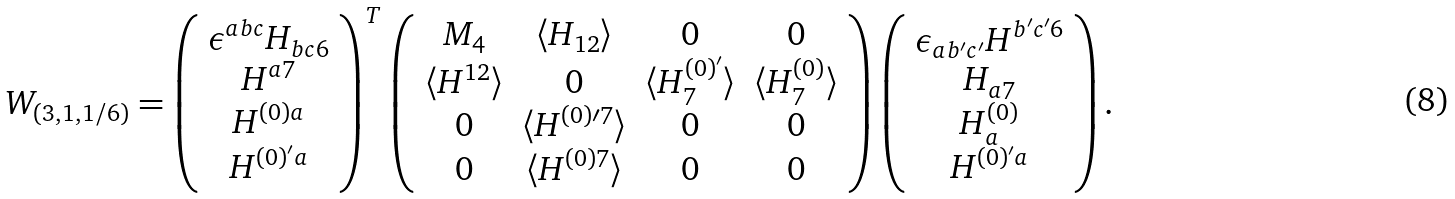<formula> <loc_0><loc_0><loc_500><loc_500>W _ { ( 3 , 1 , 1 / 6 ) } = \left ( \begin{array} { c } \epsilon ^ { a b c } H _ { b c 6 } \\ H ^ { a 7 } \\ H ^ { ( 0 ) a } \\ H ^ { ( 0 ) ^ { \prime } a } \end{array} \right ) ^ { T } \left ( \begin{array} { c c c c } M _ { 4 } & \langle H _ { 1 2 } \rangle & 0 & 0 \\ \langle H ^ { 1 2 } \rangle & 0 & \langle H ^ { ( 0 ) ^ { \prime } } _ { 7 } \rangle & \langle H ^ { ( 0 ) } _ { 7 } \rangle \\ 0 & \langle H ^ { ( 0 ) \prime 7 } \rangle & 0 & 0 \\ 0 & \langle H ^ { ( 0 ) 7 } \rangle & 0 & 0 \\ \end{array} \right ) \left ( \begin{array} { c } \epsilon _ { a b ^ { \prime } c ^ { \prime } } H ^ { b ^ { \prime } c ^ { \prime } 6 } \\ H _ { a 7 } \\ H ^ { ( 0 ) } _ { a } \\ H ^ { ( 0 ) ^ { \prime } a } \end{array} \right ) .</formula> 